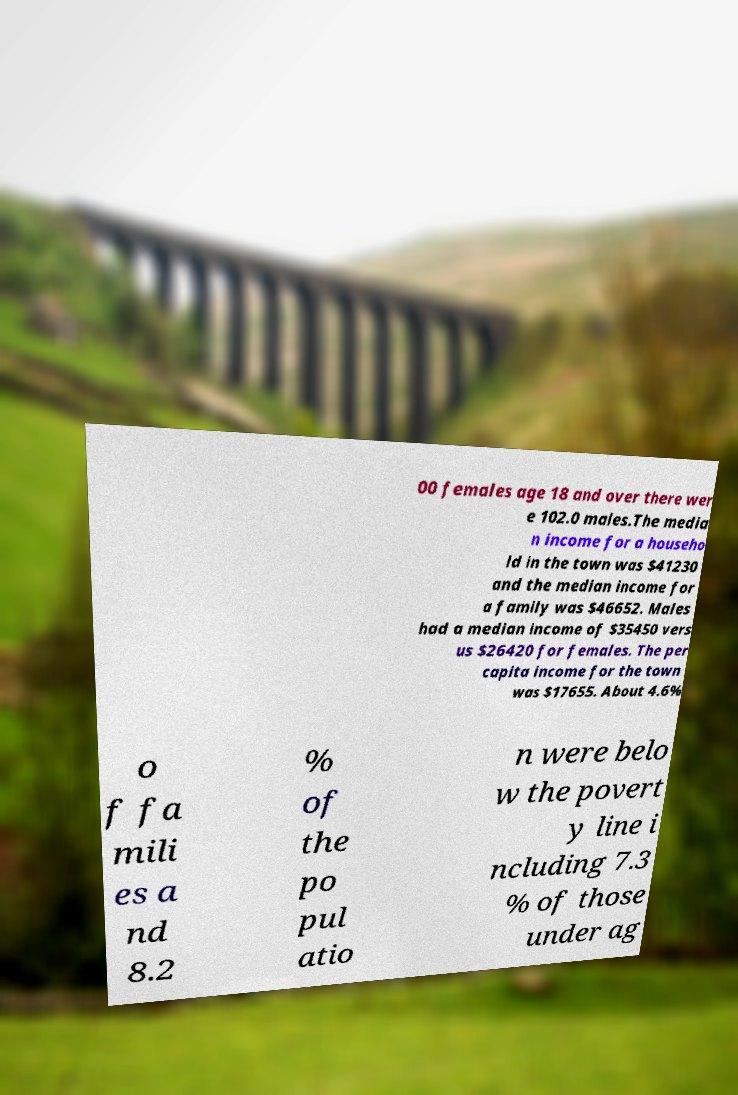Can you read and provide the text displayed in the image?This photo seems to have some interesting text. Can you extract and type it out for me? 00 females age 18 and over there wer e 102.0 males.The media n income for a househo ld in the town was $41230 and the median income for a family was $46652. Males had a median income of $35450 vers us $26420 for females. The per capita income for the town was $17655. About 4.6% o f fa mili es a nd 8.2 % of the po pul atio n were belo w the povert y line i ncluding 7.3 % of those under ag 